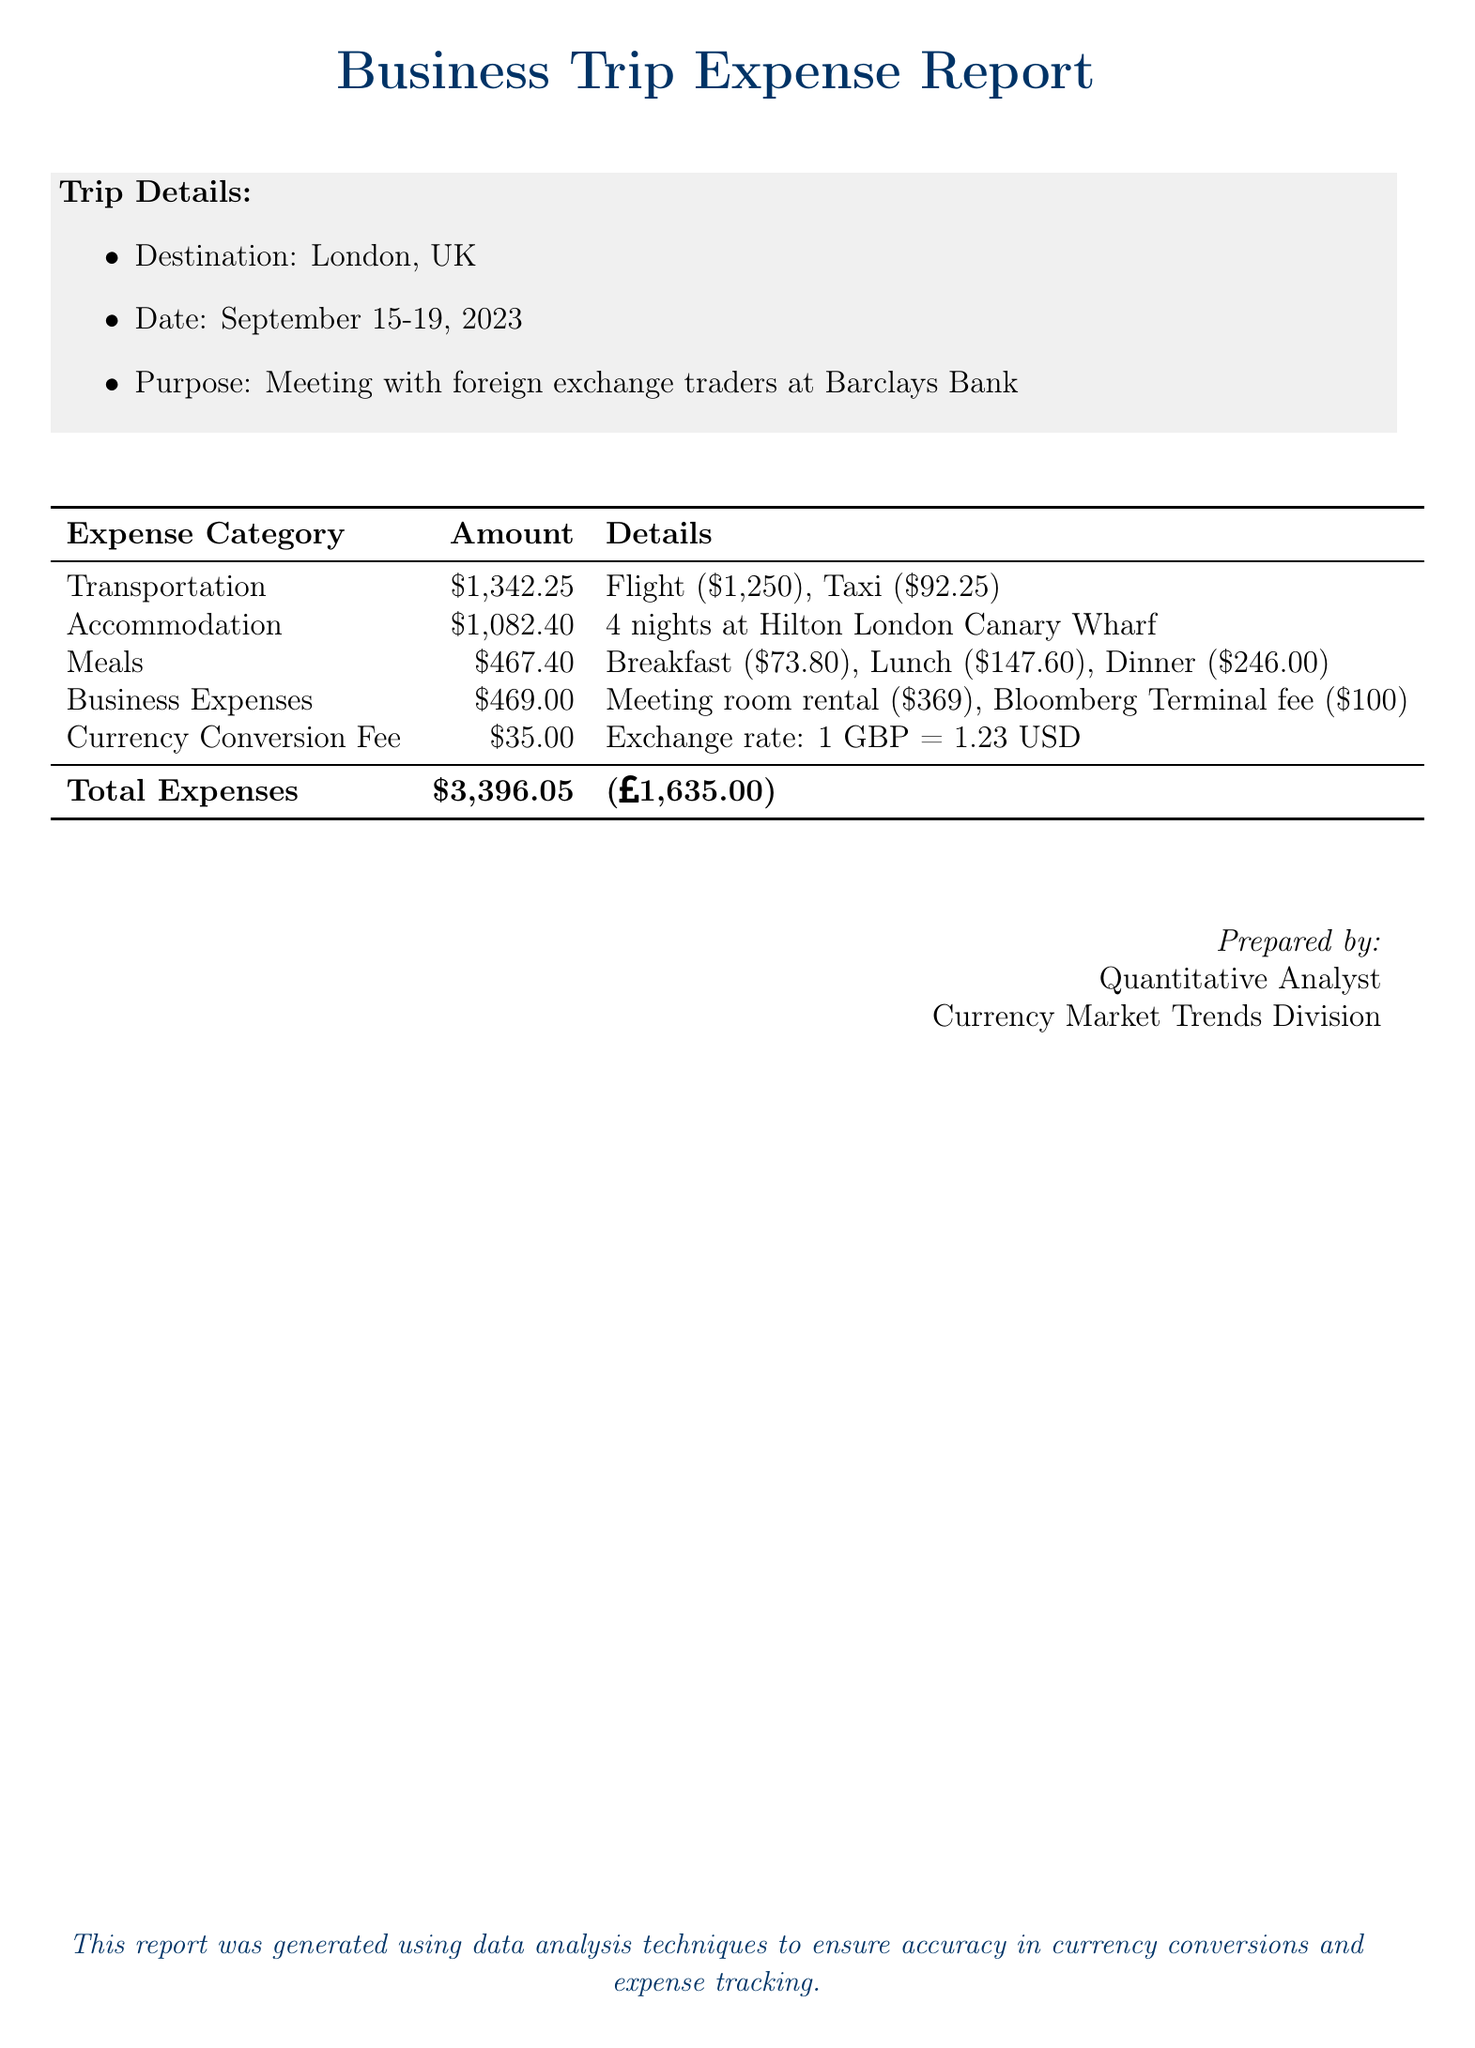What was the destination of the trip? The destination of the trip is stated in the trip details section of the document.
Answer: London, UK How many nights did the accommodation last? The accommodation duration is found in the second row of the expense report table.
Answer: 4 nights What was the total amount spent? The total expenses are summarized at the bottom of the table, alongside the currency equivalent.
Answer: $3,396.05 What was the cost of the flight? The flight cost is specified as part of the transportation expense details in the table.
Answer: $1,250 What is the currency conversion fee? The currency conversion fee is detailed in the expense report table specifically under its own category.
Answer: $35.00 What was the purpose of the trip? The purpose of the trip is listed in the trip details section of the document.
Answer: Meeting with foreign exchange traders What was the exchange rate mentioned in the report? The exchange rate is provided in the details for the currency conversion fee line item.
Answer: 1 GBP = 1.23 USD How much was spent on meals? The total spent on meals is detailed in the expense report table's meals category.
Answer: $467.40 What company was met during the trip? The company met during the trip is specified in the purpose section of the trip details.
Answer: Barclays Bank 